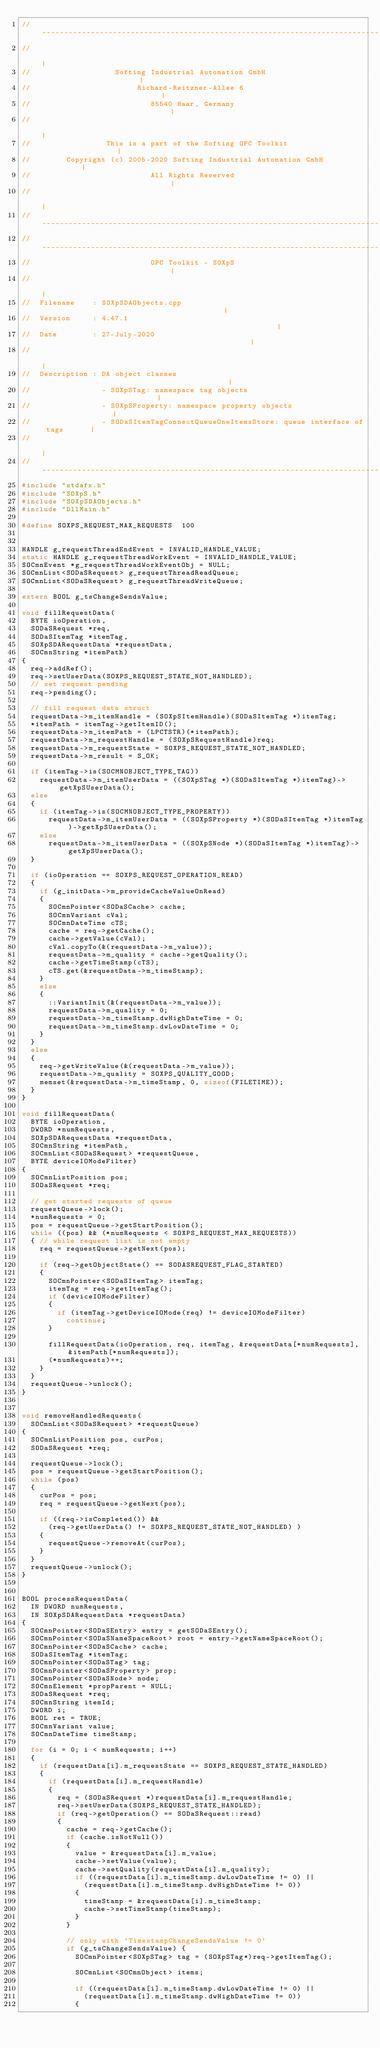<code> <loc_0><loc_0><loc_500><loc_500><_C++_>//-----------------------------------------------------------------------------
//                                                                            |
//                   Softing Industrial Automation GmbH                       |
//                        Richard-Reitzner-Allee 6                            |
//                           85540 Haar, Germany                              |
//                                                                            |
//                 This is a part of the Softing OPC Toolkit                  |
//        Copyright (c) 2005-2020 Softing Industrial Automation GmbH          |
//                           All Rights Reserved                              |
//                                                                            |
//-----------------------------------------------------------------------------
//-----------------------------------------------------------------------------
//                           OPC Toolkit - SOXpS                              |
//                                                                            |
//  Filename    : SOXpSDAObjects.cpp                                          |
//  Version     : 4.47.1                                                      |
//  Date        : 27-July-2020                                                |
//                                                                            |
//  Description : DA object classes                                           |
//                - SOXpSTag: namespace tag objects                           |
//                - SOXpSProperty: namespace property objects                 |
//                - SODaSItemTagConnectQueueOneItemsStore: queue interface of tags      |
//                                                                            |
//-----------------------------------------------------------------------------
#include "stdafx.h"
#include "SOXpS.h"
#include "SOXpSDAObjects.h"
#include "DllMain.h"

#define SOXPS_REQUEST_MAX_REQUESTS	100


HANDLE g_requestThreadEndEvent = INVALID_HANDLE_VALUE;
static HANDLE g_requestThreadWorkEvent = INVALID_HANDLE_VALUE;
SOCmnEvent *g_requestThreadWorkEventObj = NULL;
SOCmnList<SODaSRequest> g_requestThreadReadQueue;
SOCmnList<SODaSRequest> g_requestThreadWriteQueue;

extern BOOL g_tsChangeSendsValue;

void fillRequestData(
	BYTE ioOperation,
	SODaSRequest *req,
	SODaSItemTag *itemTag,
	SOXpSDARequestData *requestData,
	SOCmnString *itemPath)
{
	req->addRef();
	req->setUserData(SOXPS_REQUEST_STATE_NOT_HANDLED);
	// set request pending
	req->pending();

	// fill request data struct
	requestData->m_itemHandle = (SOXpSItemHandle)(SODaSItemTag *)itemTag;
	*itemPath = itemTag->getItemID();
	requestData->m_itemPath = (LPCTSTR)(*itemPath);
	requestData->m_requestHandle = (SOXpSRequestHandle)req;
	requestData->m_requestState = SOXPS_REQUEST_STATE_NOT_HANDLED;
	requestData->m_result = S_OK;

	if (itemTag->is(SOCMNOBJECT_TYPE_TAG))
		requestData->m_itemUserData = ((SOXpSTag *)(SODaSItemTag *)itemTag)->getXpSUserData();
	else
	{
		if (itemTag->is(SOCMNOBJECT_TYPE_PROPERTY))
			requestData->m_itemUserData = ((SOXpSProperty *)(SODaSItemTag *)itemTag)->getXpSUserData();
		else
			requestData->m_itemUserData = ((SOXpSNode *)(SODaSItemTag *)itemTag)->getXpSUserData();
	}

	if (ioOperation == SOXPS_REQUEST_OPERATION_READ)
	{
		if (g_initData->m_provideCacheValueOnRead)
		{
			SOCmnPointer<SODaSCache> cache;
			SOCmnVariant cVal;
			SOCmnDateTime cTS;
			cache = req->getCache();
			cache->getValue(cVal);
			cVal.copyTo(&(requestData->m_value));
			requestData->m_quality = cache->getQuality();
			cache->getTimeStamp(cTS);
			cTS.get(&requestData->m_timeStamp);
		}
		else
		{
			::VariantInit(&(requestData->m_value));
			requestData->m_quality = 0;
			requestData->m_timeStamp.dwHighDateTime = 0;
			requestData->m_timeStamp.dwLowDateTime = 0;
		}
	}
	else
	{
		req->getWriteValue(&(requestData->m_value));
		requestData->m_quality = SOXPS_QUALITY_GOOD;
		memset(&requestData->m_timeStamp, 0, sizeof(FILETIME));
	}
}

void fillRequestData(
	BYTE ioOperation,
	DWORD *numRequests,
	SOXpSDARequestData *requestData,
	SOCmnString *itemPath,
	SOCmnList<SODaSRequest> *requestQueue,
	BYTE deviceIOModeFilter)
{
	SOCmnListPosition pos;
	SODaSRequest *req;

	// get started requests of queue
	requestQueue->lock();
	*numRequests = 0;
	pos = requestQueue->getStartPosition();
	while ((pos) && (*numRequests < SOXPS_REQUEST_MAX_REQUESTS))
	{ // while request list is not empty
		req = requestQueue->getNext(pos);

		if (req->getObjectState() == SODASREQUEST_FLAG_STARTED)
		{
			SOCmnPointer<SODaSItemTag> itemTag;
			itemTag = req->getItemTag();
			if (deviceIOModeFilter)
			{
				if (itemTag->getDeviceIOMode(req) != deviceIOModeFilter)
					continue;
			}

			fillRequestData(ioOperation, req, itemTag, &requestData[*numRequests], &itemPath[*numRequests]);
			(*numRequests)++;
		}
	}
	requestQueue->unlock();
}


void removeHandledRequests(
	SOCmnList<SODaSRequest> *requestQueue)
{
	SOCmnListPosition pos, curPos;
	SODaSRequest *req;

	requestQueue->lock();
	pos = requestQueue->getStartPosition();
	while (pos)
	{
		curPos = pos;
		req = requestQueue->getNext(pos);

		if ((req->isCompleted()) &&
			(req->getUserData() != SOXPS_REQUEST_STATE_NOT_HANDLED) )
		{
			requestQueue->removeAt(curPos);
		}
	}
	requestQueue->unlock();
}


BOOL processRequestData(
	IN DWORD numRequests,
	IN SOXpSDARequestData *requestData)
{
	SOCmnPointer<SODaSEntry> entry = getSODaSEntry();
	SOCmnPointer<SODaSNameSpaceRoot> root = entry->getNameSpaceRoot();
	SOCmnPointer<SODaSCache> cache;
	SODaSItemTag *itemTag;
	SOCmnPointer<SODaSTag> tag;
	SOCmnPointer<SODaSProperty> prop;
	SOCmnPointer<SODaSNode> node;
	SOCmnElement *propParent = NULL;
	SODaSRequest *req;
	SOCmnString itemId;
	DWORD i;
	BOOL ret = TRUE;
	SOCmnVariant value;
	SOCmnDateTime timeStamp;

	for (i = 0; i < numRequests; i++)
	{
		if (requestData[i].m_requestState == SOXPS_REQUEST_STATE_HANDLED)
		{
			if (requestData[i].m_requestHandle)
			{
				req = (SODaSRequest *)requestData[i].m_requestHandle;
				req->setUserData(SOXPS_REQUEST_STATE_HANDLED);
				if (req->getOperation() == SODaSRequest::read)
				{
					cache = req->getCache();
					if (cache.isNotNull())
					{
						value = &requestData[i].m_value;
						cache->setValue(value);
						cache->setQuality(requestData[i].m_quality);
						if ((requestData[i].m_timeStamp.dwLowDateTime != 0) ||
							(requestData[i].m_timeStamp.dwHighDateTime != 0))
						{
							timeStamp = &requestData[i].m_timeStamp;
							cache->setTimeStamp(timeStamp);
						}
					}

					// only with 'TimestampChangeSendsValue != 0'
					if (g_tsChangeSendsValue)	{
						SOCmnPointer<SOXpSTag> tag = (SOXpSTag*)req->getItemTag();

						SOCmnList<SOCmnObject> items;

						if ((requestData[i].m_timeStamp.dwLowDateTime != 0) ||
							(requestData[i].m_timeStamp.dwHighDateTime != 0))
						{</code> 